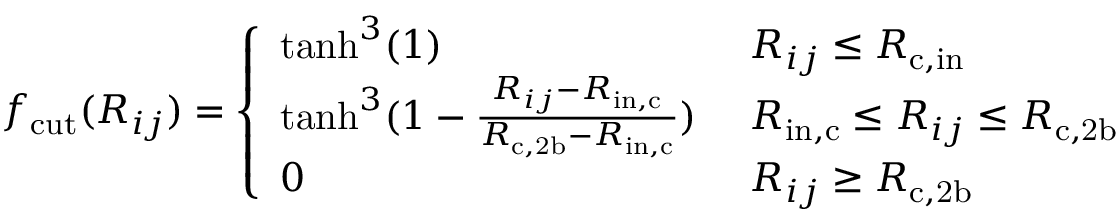<formula> <loc_0><loc_0><loc_500><loc_500>f _ { c u t } ( R _ { i j } ) = \left \{ \begin{array} { l l } { t a n h ^ { 3 } ( 1 ) } & { \ R _ { i j } \leq R _ { c , i n } } \\ { t a n h ^ { 3 } ( 1 - \frac { R _ { i j } - R _ { i n , c } } { R _ { c , 2 b } - R _ { i n , c } } ) } & { \ R _ { i n , c } \leq R _ { i j } \leq R _ { c , 2 b } } \\ { 0 } & { \ R _ { i j } \geq R _ { c , 2 b } } \end{array}</formula> 